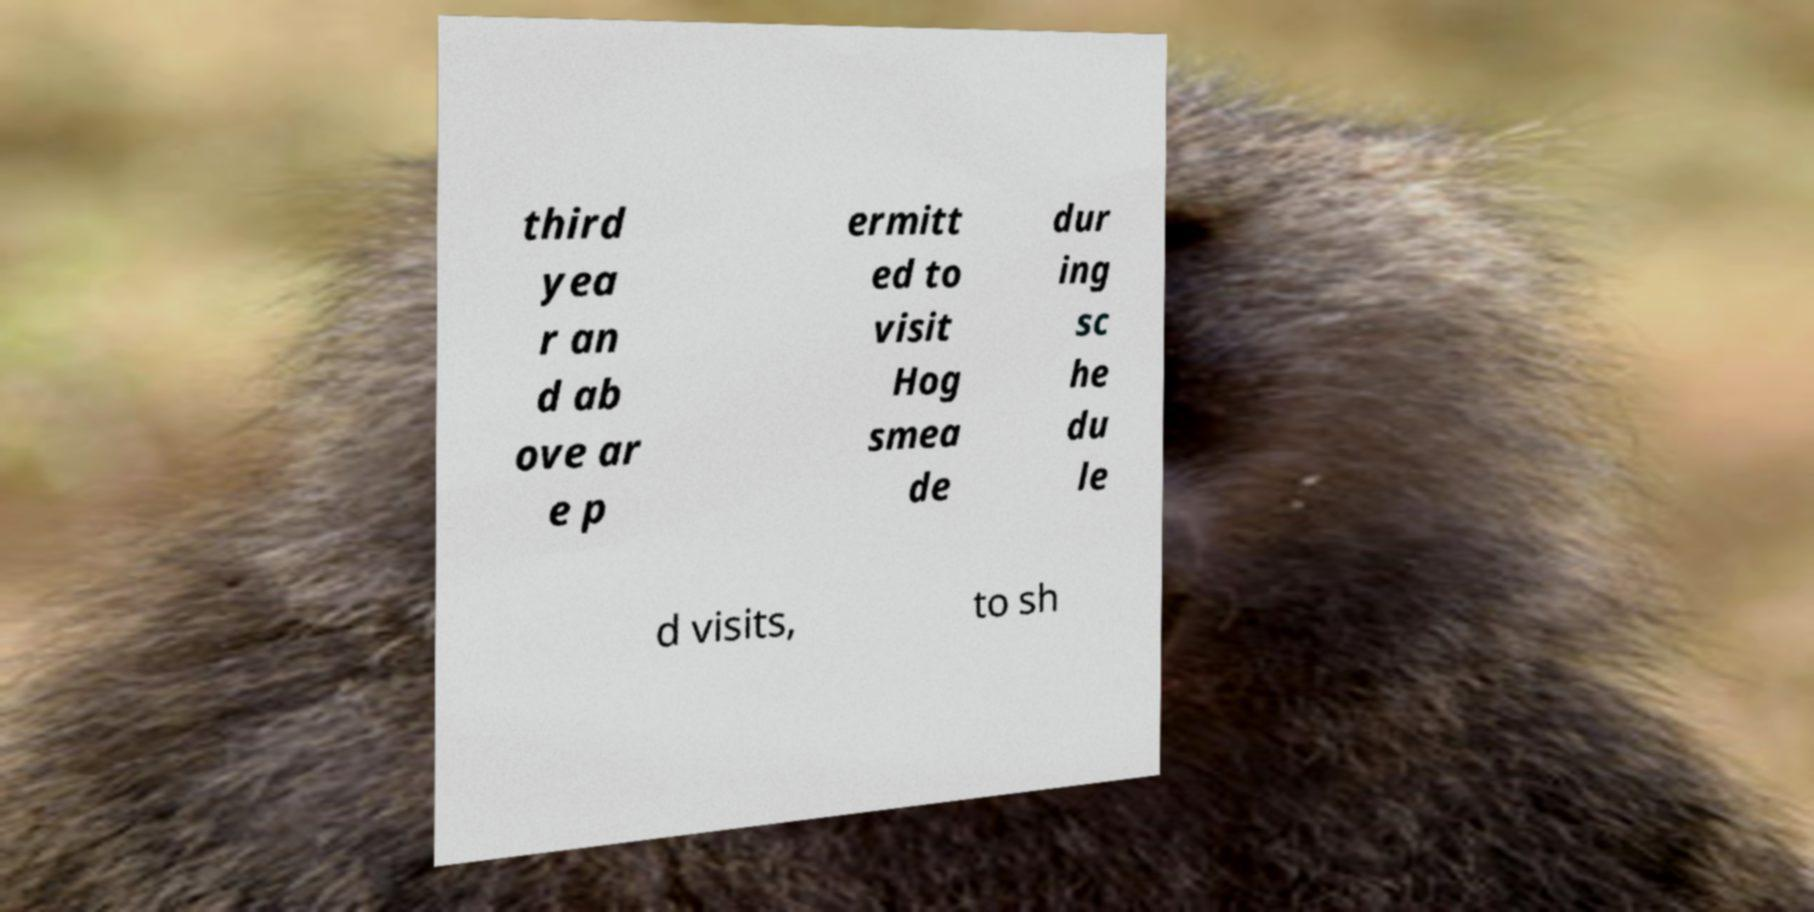Could you extract and type out the text from this image? third yea r an d ab ove ar e p ermitt ed to visit Hog smea de dur ing sc he du le d visits, to sh 